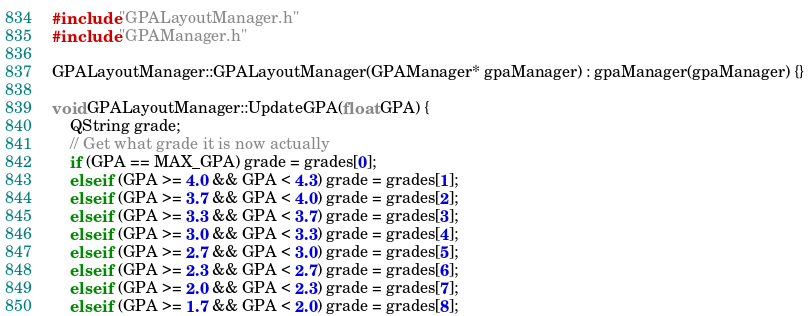Convert code to text. <code><loc_0><loc_0><loc_500><loc_500><_C++_>#include "GPALayoutManager.h"
#include "GPAManager.h"

GPALayoutManager::GPALayoutManager(GPAManager* gpaManager) : gpaManager(gpaManager) {}

void GPALayoutManager::UpdateGPA(float GPA) {
    QString grade;
    // Get what grade it is now actually
    if (GPA == MAX_GPA) grade = grades[0];
    else if (GPA >= 4.0 && GPA < 4.3) grade = grades[1];
    else if (GPA >= 3.7 && GPA < 4.0) grade = grades[2];
    else if (GPA >= 3.3 && GPA < 3.7) grade = grades[3];
    else if (GPA >= 3.0 && GPA < 3.3) grade = grades[4];
    else if (GPA >= 2.7 && GPA < 3.0) grade = grades[5];
    else if (GPA >= 2.3 && GPA < 2.7) grade = grades[6];
    else if (GPA >= 2.0 && GPA < 2.3) grade = grades[7];
    else if (GPA >= 1.7 && GPA < 2.0) grade = grades[8];</code> 